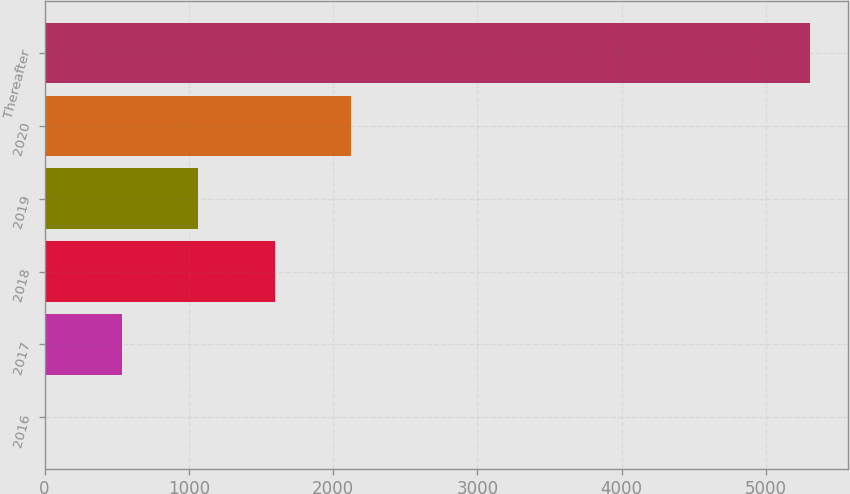Convert chart to OTSL. <chart><loc_0><loc_0><loc_500><loc_500><bar_chart><fcel>2016<fcel>2017<fcel>2018<fcel>2019<fcel>2020<fcel>Thereafter<nl><fcel>4.7<fcel>534.68<fcel>1594.64<fcel>1064.66<fcel>2124.62<fcel>5304.5<nl></chart> 